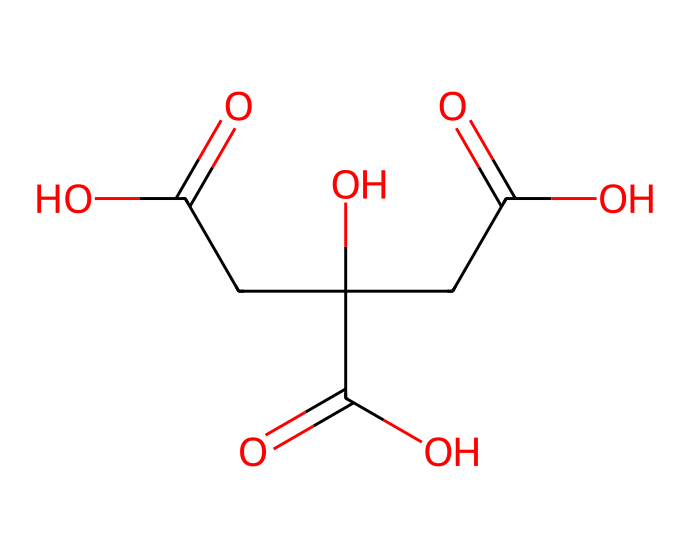What is the name of this chemical? The SMILES representation corresponds to citric acid, a well-known organic acid.
Answer: citric acid How many carbon atoms are in this chemical? Counting the carbon atoms in the SMILES structure, we find a total of six carbon atoms.
Answer: 6 What functional groups are present in this chemical? In citric acid, there are three carboxylic acid functional groups (-COOH) indicated by the presence of carbonyl (C=O) and hydroxyl (OH) groups.
Answer: carboxylic acids What is the total number of hydrogen atoms in this chemical? By analyzing the structure derived from the SMILES, we can conclude that citric acid has eight hydrogen atoms present in its formula.
Answer: 8 How is citric acid beneficial in energy drinks? Citric acid can enhance flavor and potentially improve energy metabolism in the body, contributing to the overall energizing effect of these drinks.
Answer: flavor enhancer Why does citric acid contribute to a sour taste? The presence of carboxylic acid groups lowers pH and contributes to the sour flavor profile typical of acids, therefore making citric acid taste sour.
Answer: sour flavor 